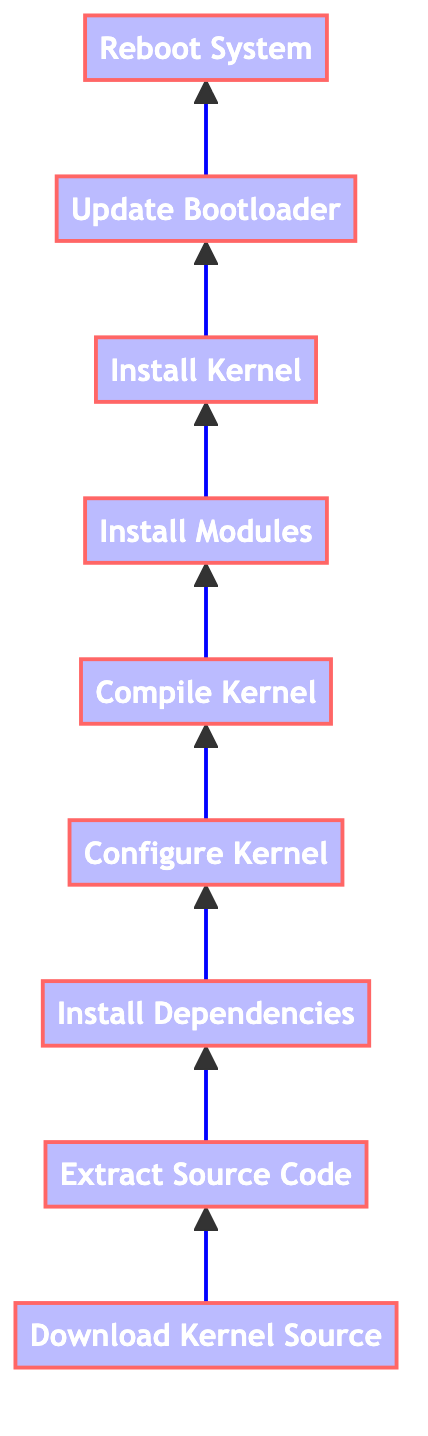What is the first step in the flow chart? The first node in the diagram is "Download Kernel Source," indicating that this is the initial step in building a custom kernel.
Answer: Download Kernel Source How many steps are there in the diagram? By counting all the nodes from the bottom to the top of the flow chart, we see there are a total of nine steps listed.
Answer: Nine What follows "Compile Kernel" in the flow chart? The node immediately after "Compile Kernel" is "Install Modules," indicating the next step in the kernel building process.
Answer: Install Modules What is the last step in the compilation process? The flow chart indicates that "Reboot System" is the final action to be taken after completing all previous steps.
Answer: Reboot System Which step comes before "Update Bootloader"? Looking at the flow, the node just prior to "Update Bootloader" is "Install Kernel," showing the sequence of actions leading to bootloader configuration.
Answer: Install Kernel Why is "Extract Source Code" important? It is a prerequisite step essential for preparing the downloaded kernel source for the subsequent configuration process, ensuring the source code is accessible.
Answer: Preparing source code Which two steps directly relate to assembling the kernel? The steps "Compile Kernel" and "Install Modules" work together to ensure the kernel is fully compiled and its modules installed correctly.
Answer: Compile Kernel and Install Modules What is required for "Configure Kernel"? This step needs to incorporate the specific system requirements and performance needs, reflected in the configuration settings chosen during kernel setup.
Answer: Configuration settings How does the flow chart depict the order of actions? The sequence of nodes moves from bottom to top, where each step must be completed before proceeding to the next in the kernel compilation process.
Answer: Bottom to top order 